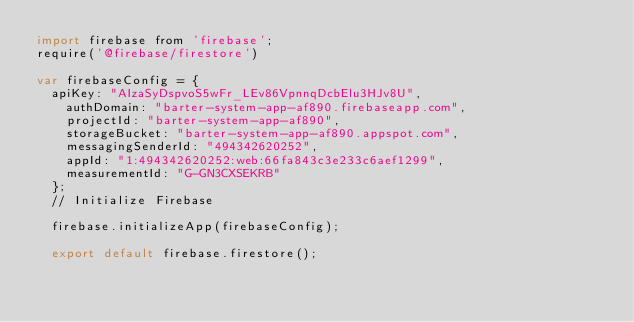Convert code to text. <code><loc_0><loc_0><loc_500><loc_500><_JavaScript_>import firebase from 'firebase';
require('@firebase/firestore')

var firebaseConfig = {
  apiKey: "AIzaSyDspvoS5wFr_LEv86VpnnqDcbElu3HJv8U",
    authDomain: "barter-system-app-af890.firebaseapp.com",
    projectId: "barter-system-app-af890",
    storageBucket: "barter-system-app-af890.appspot.com",
    messagingSenderId: "494342620252",
    appId: "1:494342620252:web:66fa843c3e233c6aef1299",
    measurementId: "G-GN3CXSEKRB"
  };
  // Initialize Firebase

  firebase.initializeApp(firebaseConfig);

  export default firebase.firestore();
</code> 